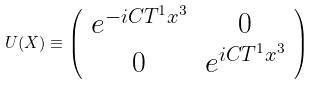Convert formula to latex. <formula><loc_0><loc_0><loc_500><loc_500>U ( X ) \equiv \left ( \begin{array} { c c } e ^ { - i C T ^ { 1 } x ^ { 3 } } & 0 \\ 0 & e ^ { i C T ^ { 1 } x ^ { 3 } } \end{array} \right )</formula> 